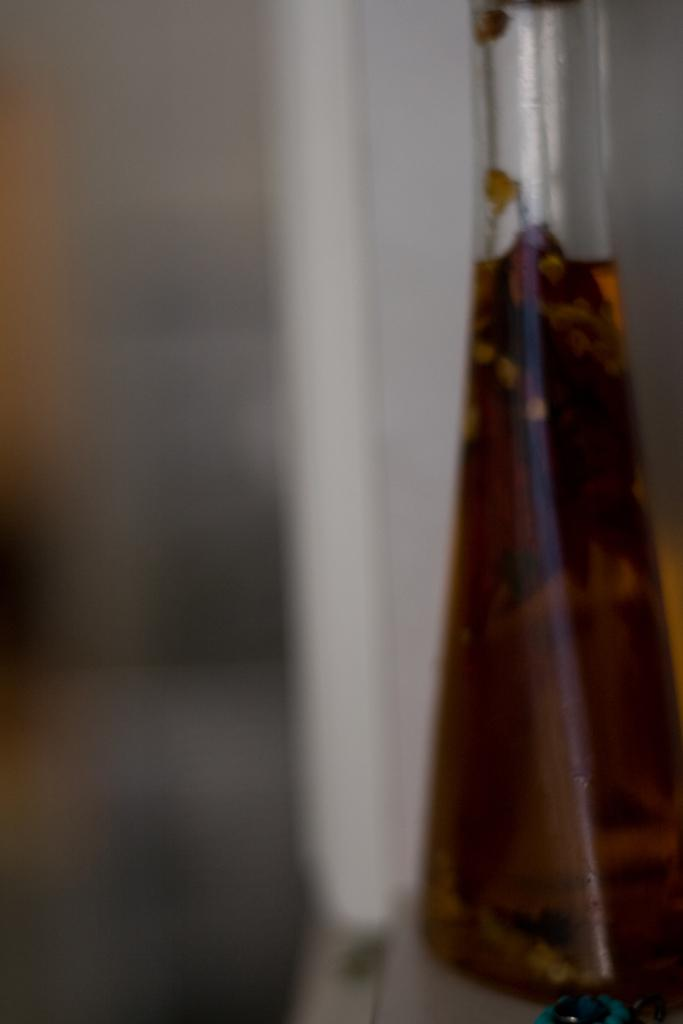What object is in the image that contains a liquid? There is a glass beaker in the image that contains a liquid. What color is the liquid in the glass beaker? The liquid in the glass beaker is brown colored. What is the color of the surface the glass beaker is placed on? The glass beaker is on a white colored surface. How would you describe the background of the image? The background of the image is blurry. What type of trade is happening in the image? There is no trade happening in the image; it features a glass beaker with a brown liquid on a white surface with a blurry background. Can you see any waves in the image? There are no waves visible in the image. 